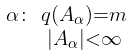<formula> <loc_0><loc_0><loc_500><loc_500>\begin{smallmatrix} \alpha \colon & q ( A _ { \alpha } ) = m \\ & | A _ { \alpha } | < \infty \end{smallmatrix}</formula> 